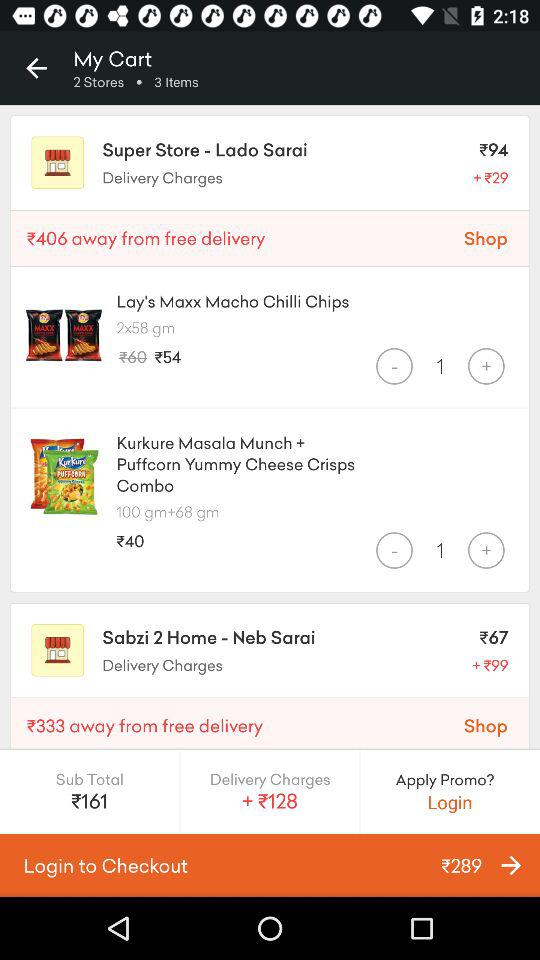What is the subtotal? The subtotal is 161 rupees. 